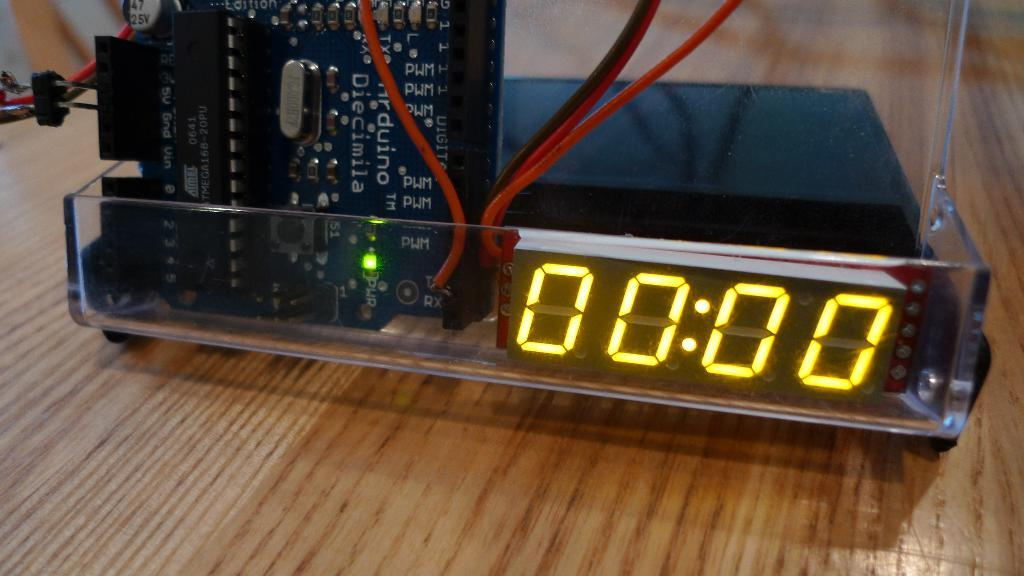<image>
Render a clear and concise summary of the photo. a digital display reading 00:00 next to red wires and computer board 